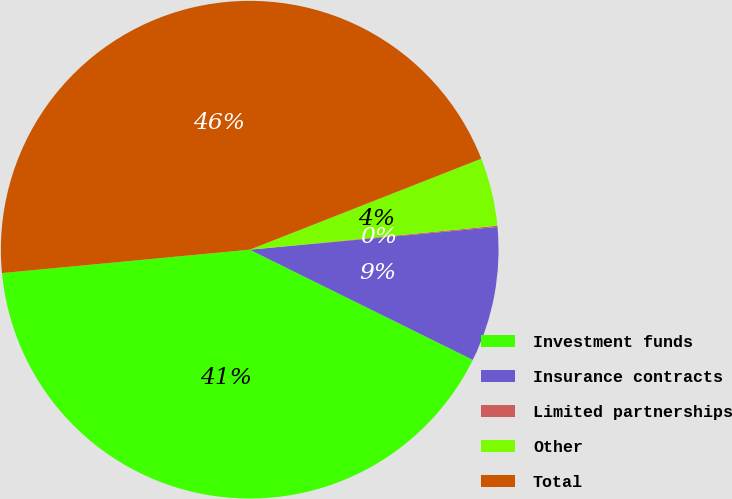<chart> <loc_0><loc_0><loc_500><loc_500><pie_chart><fcel>Investment funds<fcel>Insurance contracts<fcel>Limited partnerships<fcel>Other<fcel>Total<nl><fcel>41.2%<fcel>8.76%<fcel>0.08%<fcel>4.42%<fcel>45.54%<nl></chart> 